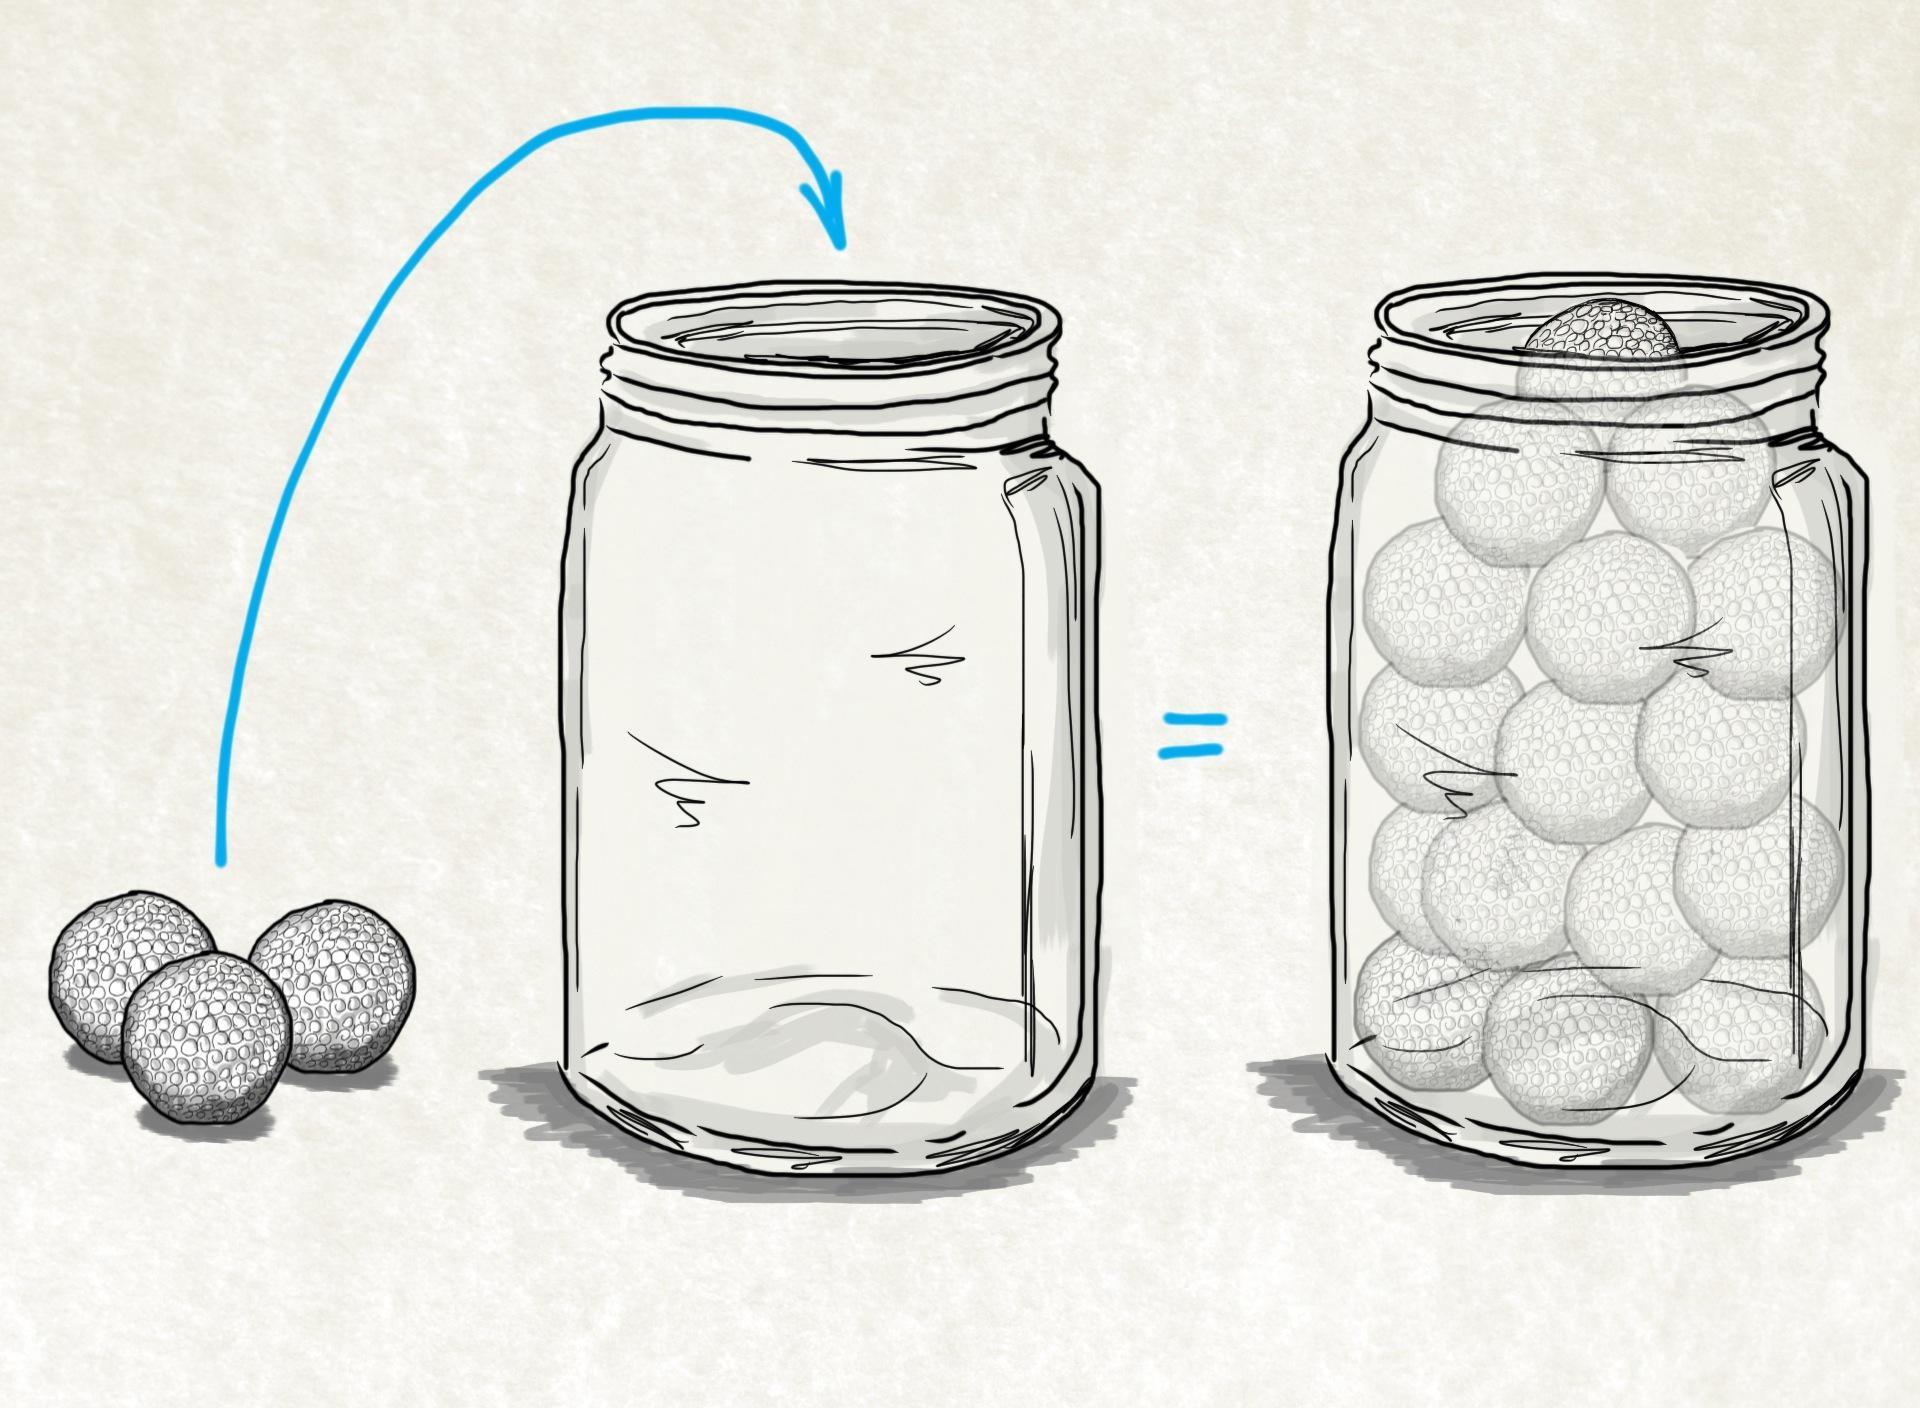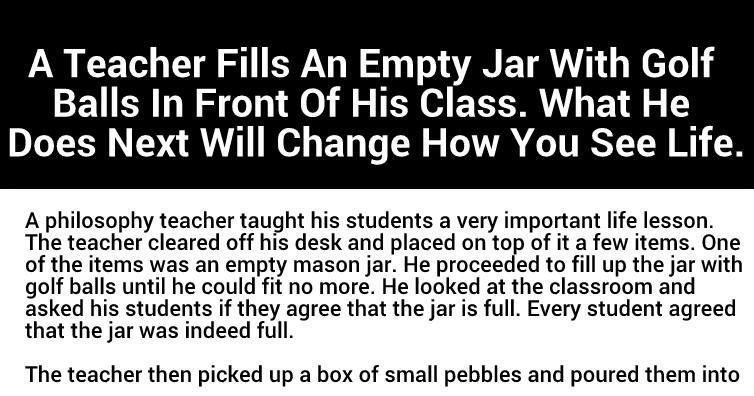The first image is the image on the left, the second image is the image on the right. Evaluate the accuracy of this statement regarding the images: "There is a glass of beer visible in one of the images.". Is it true? Answer yes or no. No. The first image is the image on the left, the second image is the image on the right. Analyze the images presented: Is the assertion "In at least one image there is at least one empty and full jar of golf balls." valid? Answer yes or no. Yes. 